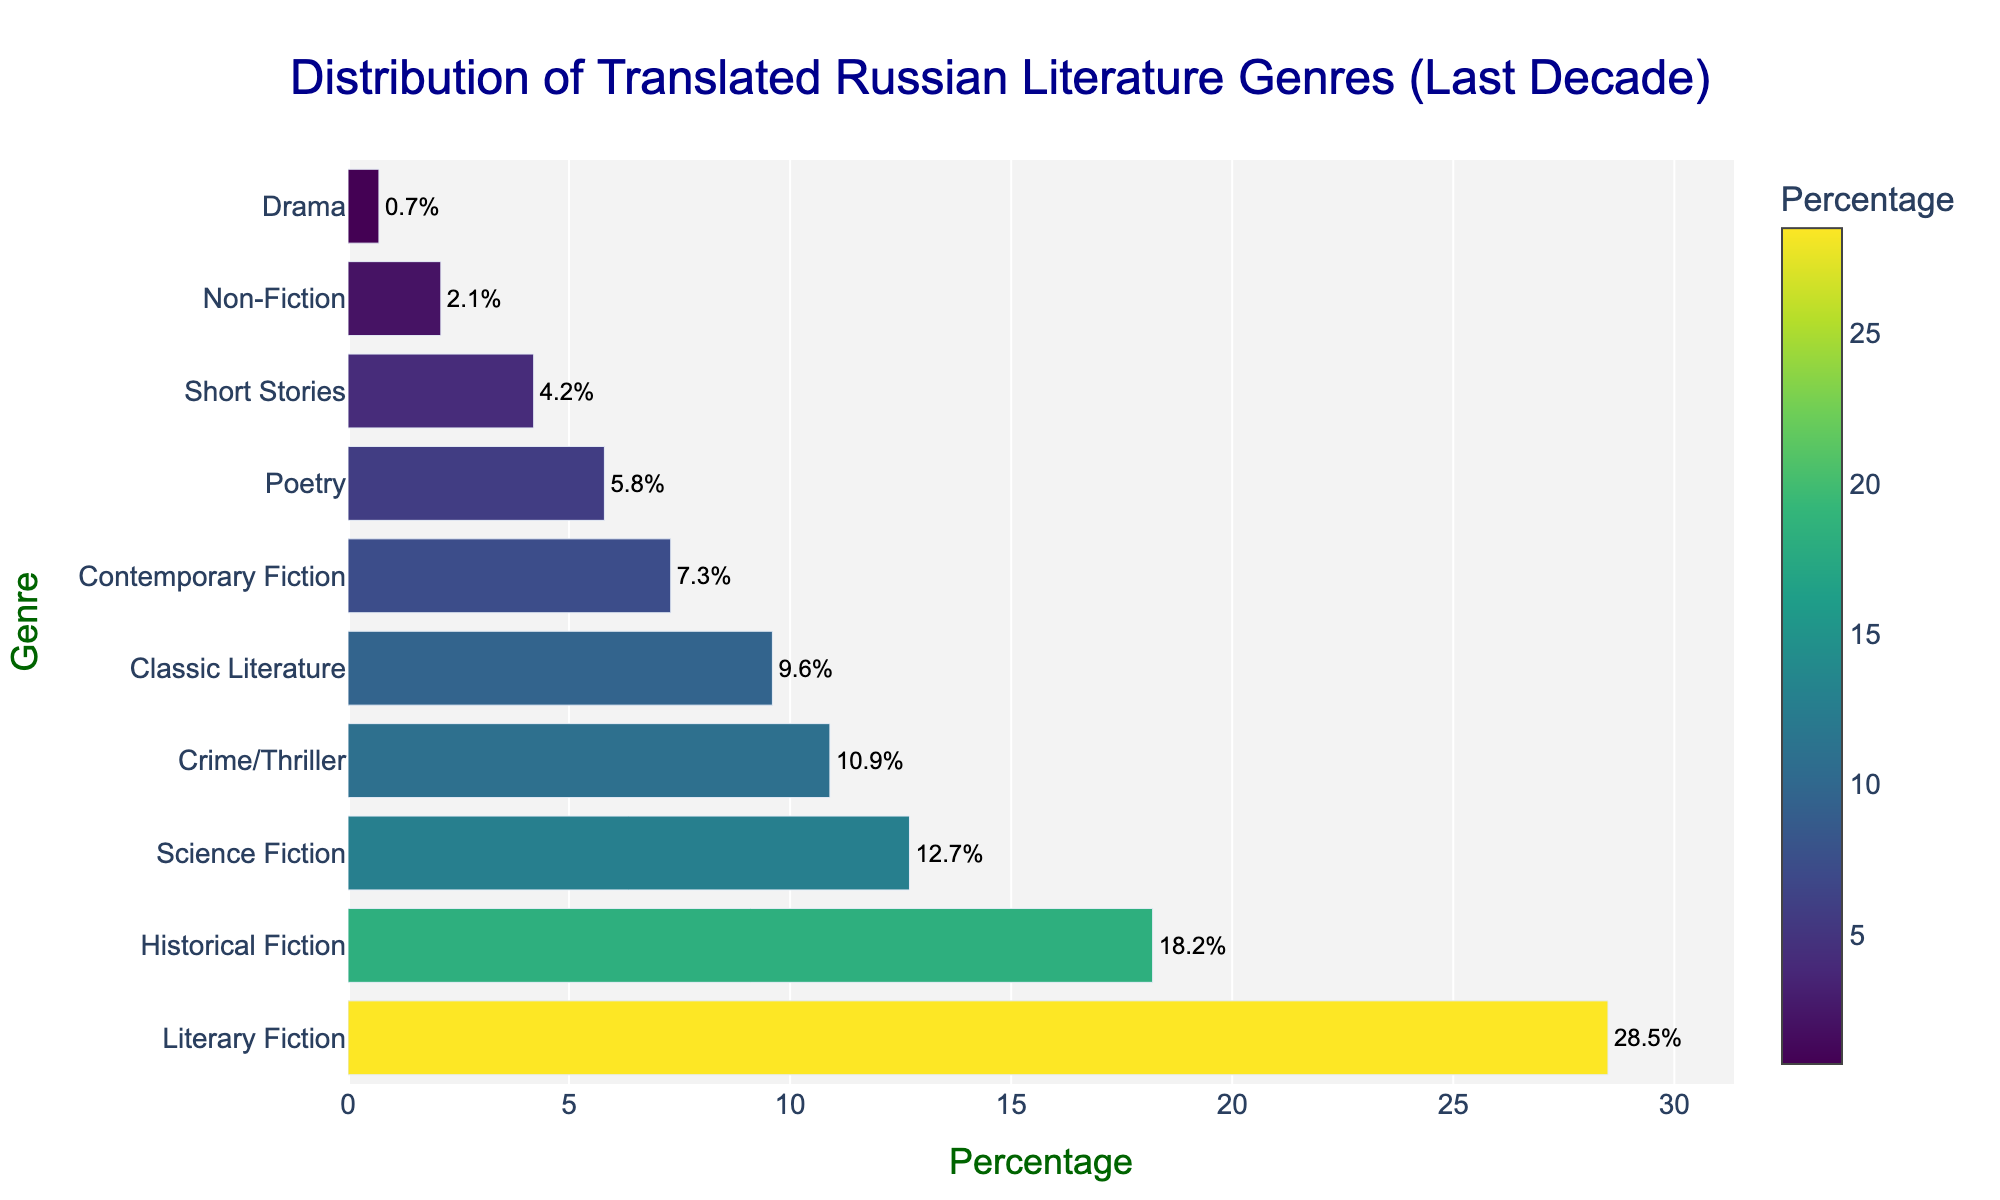What genre is the most published in the last decade? By looking at the bar chart, the genre with the highest percentage will be the longest bar. Literary Fiction has the longest bar with a percentage of 28.5%.
Answer: Literary Fiction Which genre has the lowest publication percentage? The genre at the bottom of the bar chart will have the shortest bar, representing the lowest percentage. Drama is the last genre listed with a percentage of 0.7%.
Answer: Drama What is the combined percentage of Historical Fiction and Science Fiction? The percentages for Historical Fiction and Science Fiction need to be added together. Historical Fiction has 18.2%, and Science Fiction has 12.7%. So, 18.2% + 12.7% = 30.9%.
Answer: 30.9% How does the percentage of Classic Literature compare to that of Contemporary Fiction? Compare the percentages directly from the chart. Classic Literature has 9.6%, and Contemporary Fiction has 7.3%. Classic Literature has a higher percentage than Contemporary Fiction.
Answer: Classic Literature has a higher percentage Which genre has approximately half the publication percentage of Literary Fiction? Identify genres and compare with half of Literary Fiction's percentage (28.5%/2 = 14.25%). Historical Fiction (18.2%) and Science Fiction (12.7%) are close, but Science Fiction is more approximate since it's very close to 14.25%.
Answer: Science Fiction What is the difference in publication percentages between Crime/Thriller and Poetry? The percentage of Crime/Thriller is 10.9%, and Poetry is 5.8%. Subtract 5.8% from 10.9%: 10.9% - 5.8% = 5.1%.
Answer: 5.1% Which genre between Non-Fiction and Short Stories has a greater publication percentage? Directly compare the bar lengths or percentages of Non-Fiction and Short Stories. Non-Fiction has 2.1% and Short Stories have 4.2%. Short Stories have a greater publication percentage.
Answer: Short Stories What's the sum of percentages for all genres except the top four? Sum the percentages of genres excluding Literary Fiction, Historical Fiction, Science Fiction, and Crime/Thriller. 9.6% (Classic) + 7.3% (Contemporary) + 5.8% (Poetry) + 4.2% (Short Stories) + 2.1% (Non-Fiction) + 0.7% (Drama) = 29.7%.
Answer: 29.7% How many genres have more than 10% publication percentage? Identify and count genres with a percentage greater than 10%. These are Literary Fiction, Historical Fiction, Science Fiction, and Crime/Thriller – totaling four genres.
Answer: Four genres 